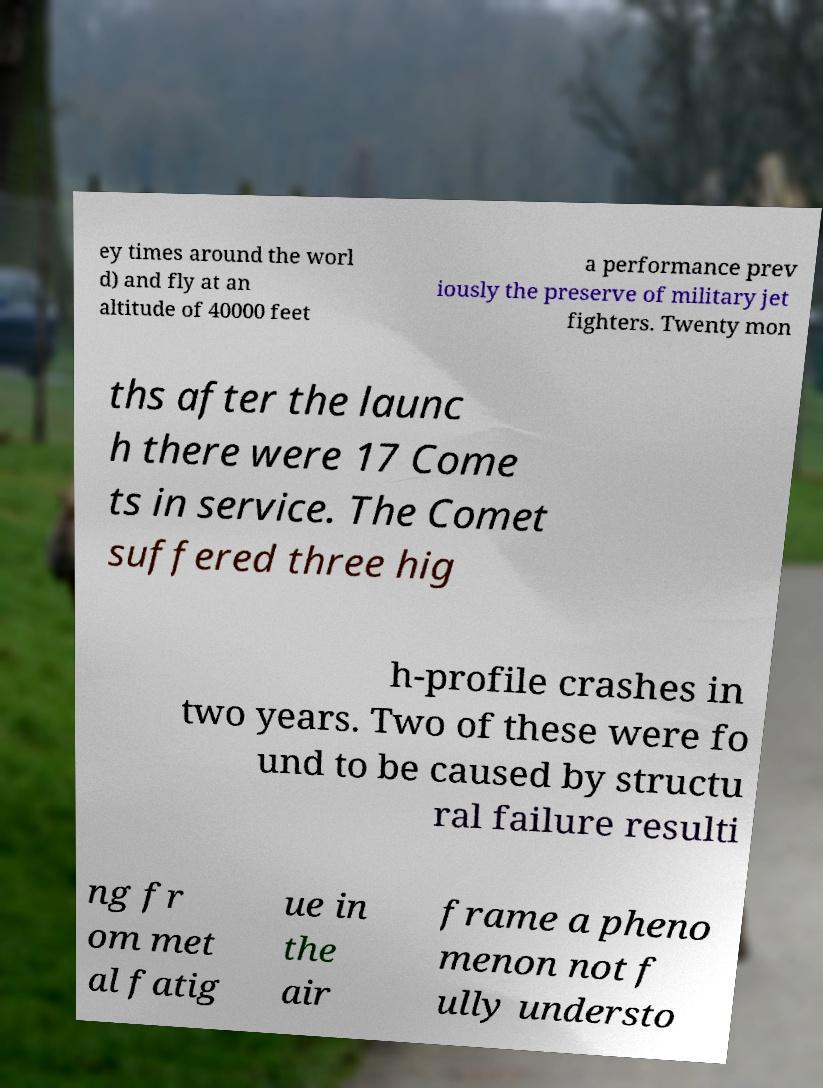For documentation purposes, I need the text within this image transcribed. Could you provide that? ey times around the worl d) and fly at an altitude of 40000 feet a performance prev iously the preserve of military jet fighters. Twenty mon ths after the launc h there were 17 Come ts in service. The Comet suffered three hig h-profile crashes in two years. Two of these were fo und to be caused by structu ral failure resulti ng fr om met al fatig ue in the air frame a pheno menon not f ully understo 